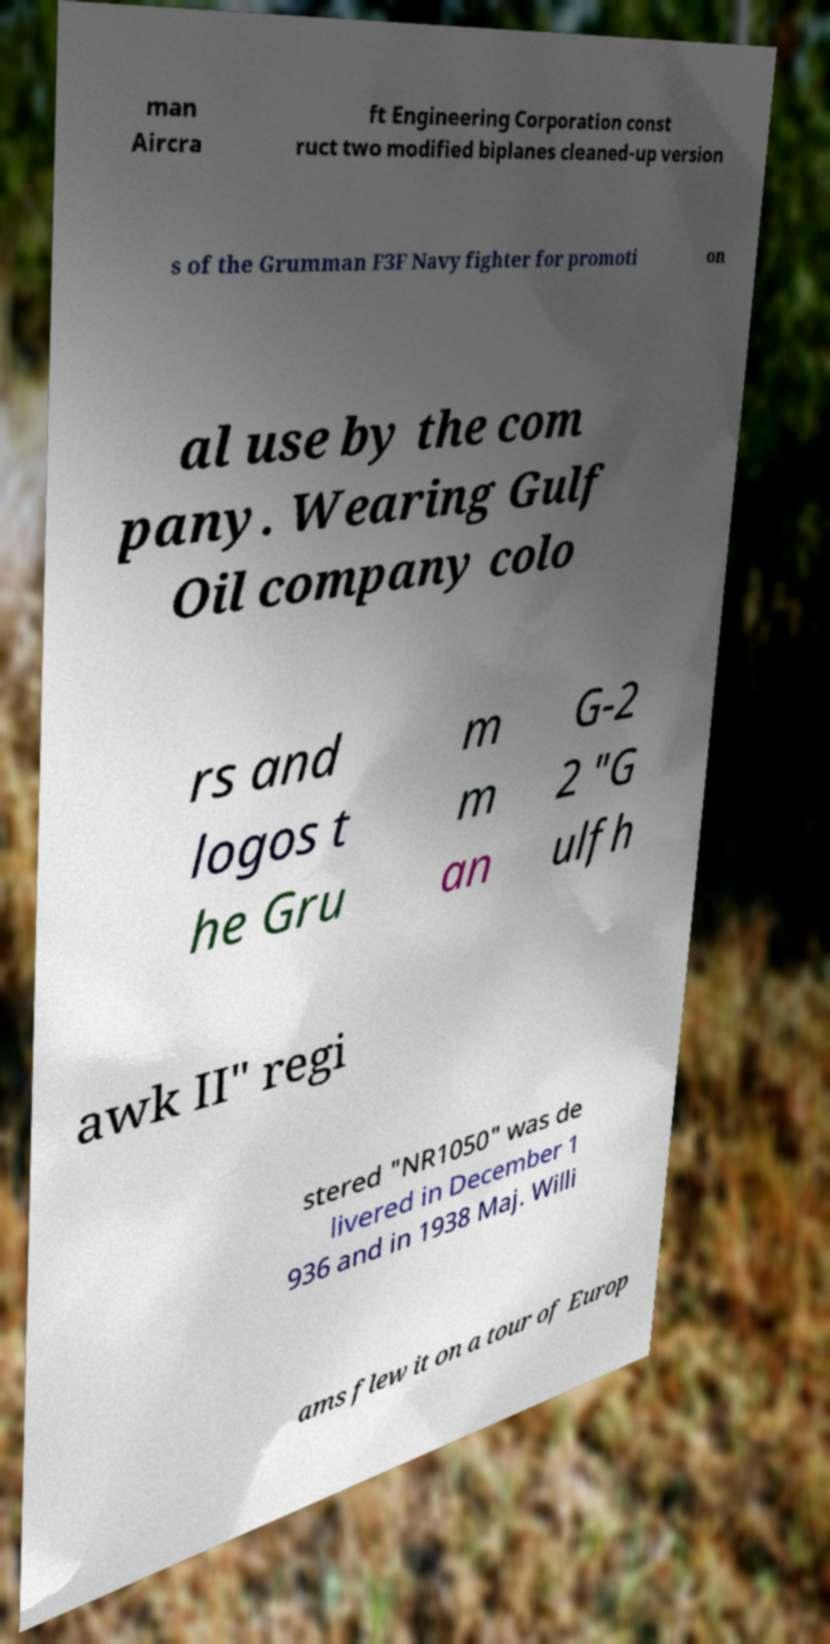Can you read and provide the text displayed in the image?This photo seems to have some interesting text. Can you extract and type it out for me? man Aircra ft Engineering Corporation const ruct two modified biplanes cleaned-up version s of the Grumman F3F Navy fighter for promoti on al use by the com pany. Wearing Gulf Oil company colo rs and logos t he Gru m m an G-2 2 "G ulfh awk II" regi stered "NR1050" was de livered in December 1 936 and in 1938 Maj. Willi ams flew it on a tour of Europ 